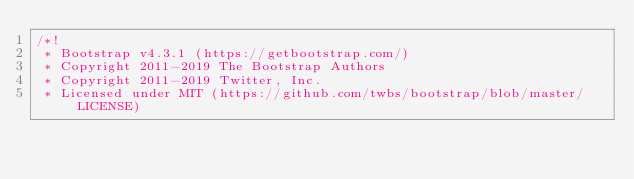<code> <loc_0><loc_0><loc_500><loc_500><_CSS_>/*!
 * Bootstrap v4.3.1 (https://getbootstrap.com/)
 * Copyright 2011-2019 The Bootstrap Authors
 * Copyright 2011-2019 Twitter, Inc.
 * Licensed under MIT (https://github.com/twbs/bootstrap/blob/master/LICENSE)</code> 